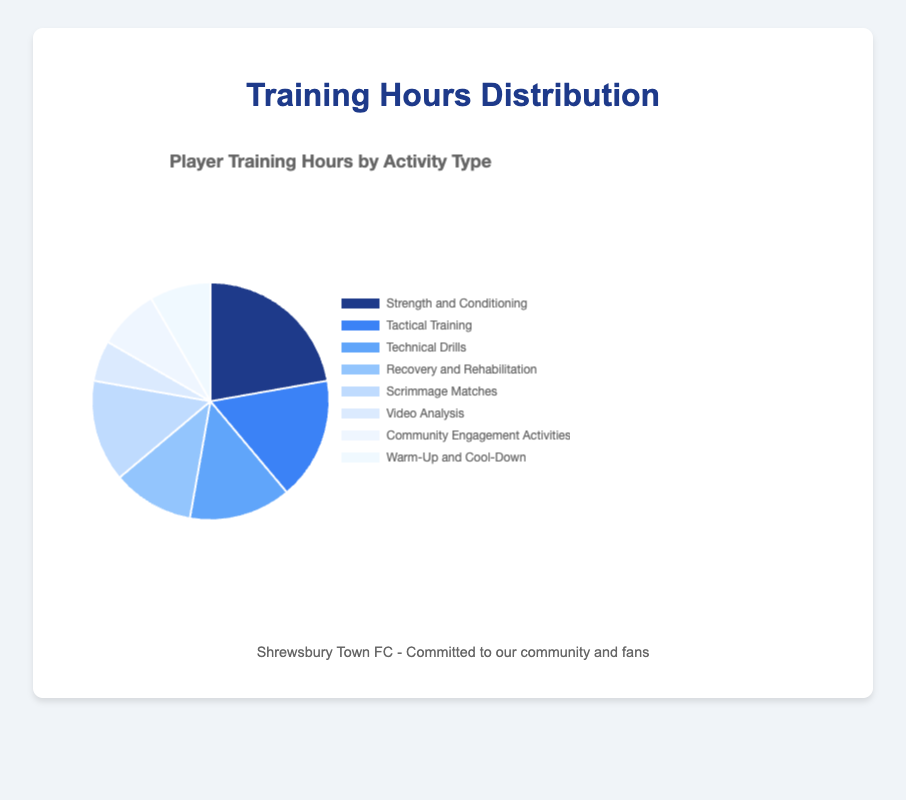what is the total number of training hours spent on "Tactical Training" and "Technical Drills"? To find the total number of hours spent on "Tactical Training" and "Technical Drills", look up the hours for both activities and add them together. Tactical Training has 6 hours and Technical Drills have 5 hours. So, 6 + 5 = 11 hours
Answer: 11 Which activity has the highest training hours? To determine which activity has the highest training hours, look for the activity with the largest segment or value in the chart. The highest training hours is assigned to "Strength and Conditioning" with 8 hours
Answer: Strength and Conditioning How many more hours are spent on "Strength and Conditioning" compared to "Video Analysis"? First, find the number of hours spent on each activity. "Strength and Conditioning" has 8 hours while "Video Analysis" has 2 hours. The difference is 8 - 2 = 6 hours
Answer: 6 Which activities have equal training hours? To find equal training hours, search for activities with the same assigned value in the chart. "Technical Drills" and "Scrimmage Matches" both have 5 hours. "Community Engagement Activities" and "Warm-Up and Cool-Down" both have 3 hours
Answer: Technical Drills and Scrimmage Matches; Community Engagement Activities and Warm-Up and Cool-Down What are the total training hours covered in the pie chart? Sum all the training hours from each activity: 8 + 6 + 5 + 4 + 5 + 2 + 3 + 3 = 36
Answer: 36 What percentage of total training hours is spent on "Recovery and Rehabilitation"? First, find the total training hours (36 hours). Then, calculate the percentage: (4 hours for Recovery and Rehabilitation / 36 total hours) * 100% = 11.11%
Answer: 11.11% Which activity uses the lightest color in the chart? Observe the chart to identify the segment filled with the lightest color. The lightest color is used for "Warm-Up and Cool-Down"
Answer: Warm-Up and Cool-Down Is the time spent on "Community Engagement Activities" more than "Video Analysis"? Compare the hours of both activities. "Community Engagement Activities" has 3 hours and "Video Analysis" has 2 hours. Since 3 is greater than 2, the answer is yes
Answer: Yes 